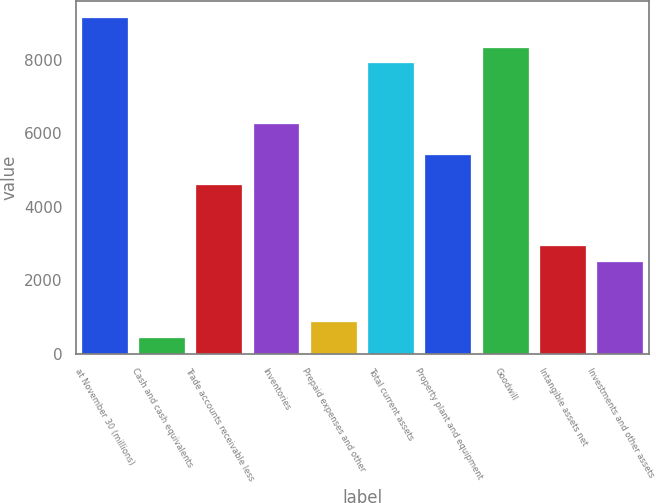Convert chart to OTSL. <chart><loc_0><loc_0><loc_500><loc_500><bar_chart><fcel>at November 30 (millions)<fcel>Cash and cash equivalents<fcel>Trade accounts receivable less<fcel>Inventories<fcel>Prepaid expenses and other<fcel>Total current assets<fcel>Property plant and equipment<fcel>Goodwill<fcel>Intangible assets net<fcel>Investments and other assets<nl><fcel>9143.12<fcel>432.11<fcel>4580.21<fcel>6239.45<fcel>846.92<fcel>7898.69<fcel>5409.83<fcel>8313.5<fcel>2920.97<fcel>2506.16<nl></chart> 